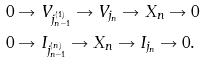Convert formula to latex. <formula><loc_0><loc_0><loc_500><loc_500>0 & \rightarrow V _ { j _ { n - 1 } ^ { ( 1 ) } } \rightarrow V _ { j _ { n } } \rightarrow X _ { n } \rightarrow 0 \\ 0 & \rightarrow I _ { j _ { n - 1 } ^ { ( n ) } } \rightarrow X _ { n } \rightarrow I _ { j _ { n } } \rightarrow 0 .</formula> 